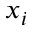<formula> <loc_0><loc_0><loc_500><loc_500>x _ { i }</formula> 